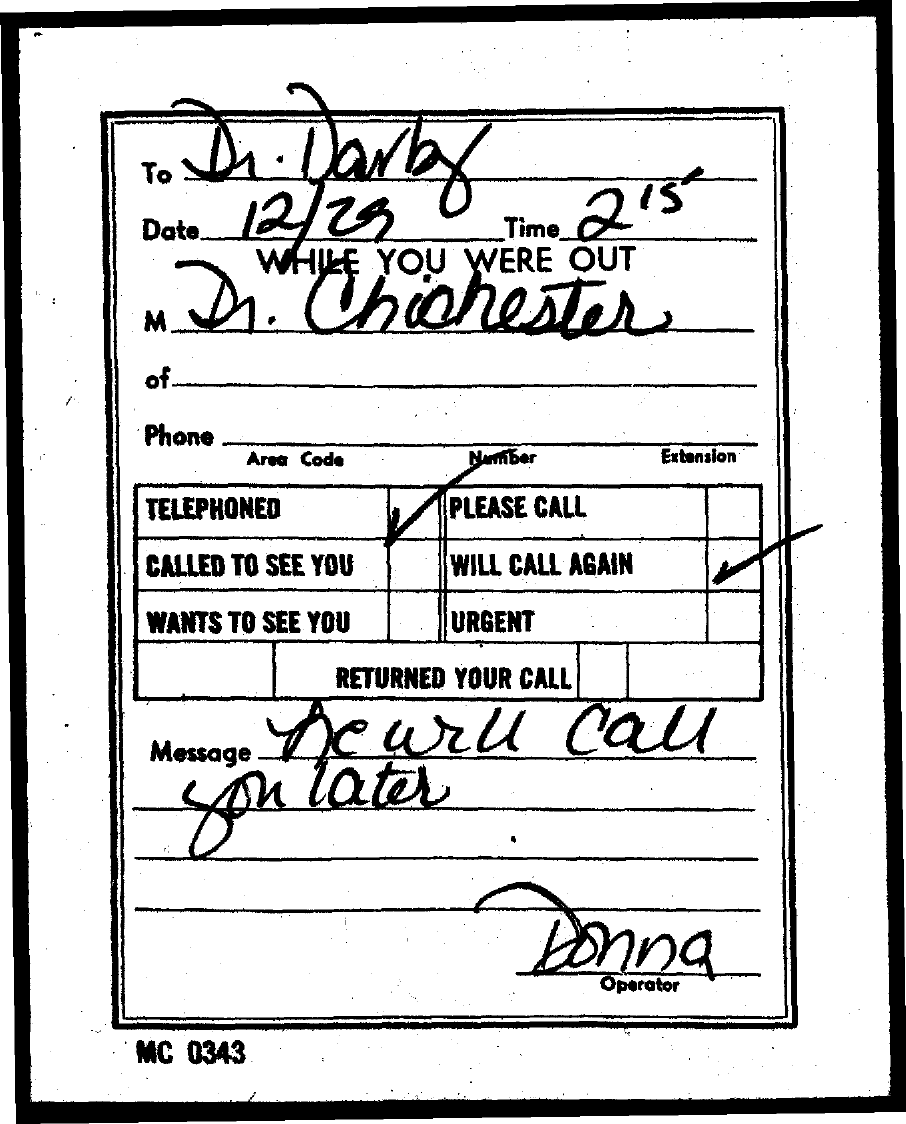Identify some key points in this picture. The operator is Donna. The note is addressed to Dr. Darby. The person who left the message was Dr. Chichester. The date is December 29. The time is 2.15.. 